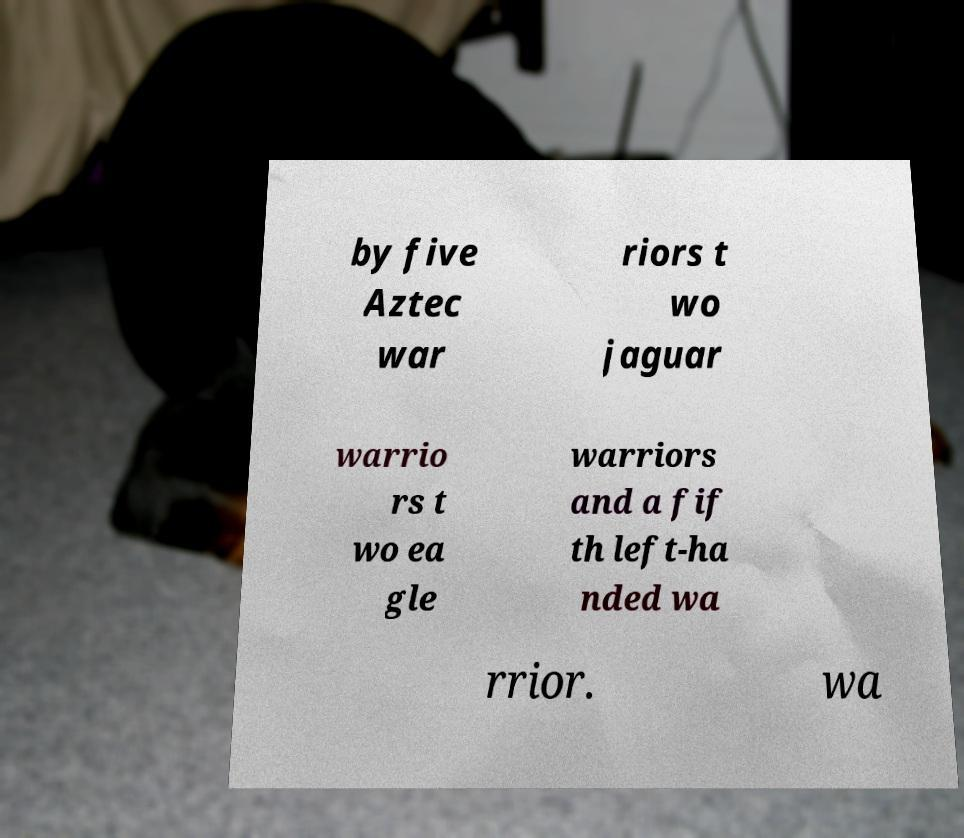What messages or text are displayed in this image? I need them in a readable, typed format. by five Aztec war riors t wo jaguar warrio rs t wo ea gle warriors and a fif th left-ha nded wa rrior. wa 